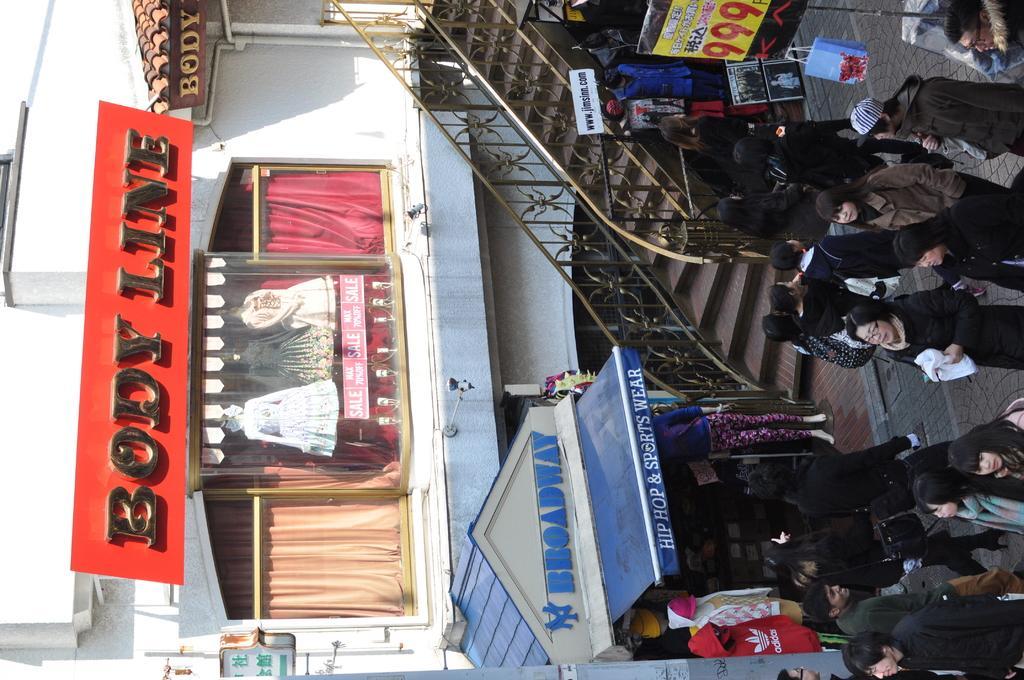Describe this image in one or two sentences. In this image there are group of person standing and walking. The woman in the center is holding a white colour object in her hand. The man at the left side is having smile on his face. In the background there are steps, building, showcase with 3 statues and with dressed, 2 curtains, and a text with red colour background with the name body-line. There is a blue colour tent with the name hip hop and sports wear and broadway with white colour background. At the right side there is a banner and some sign board. 